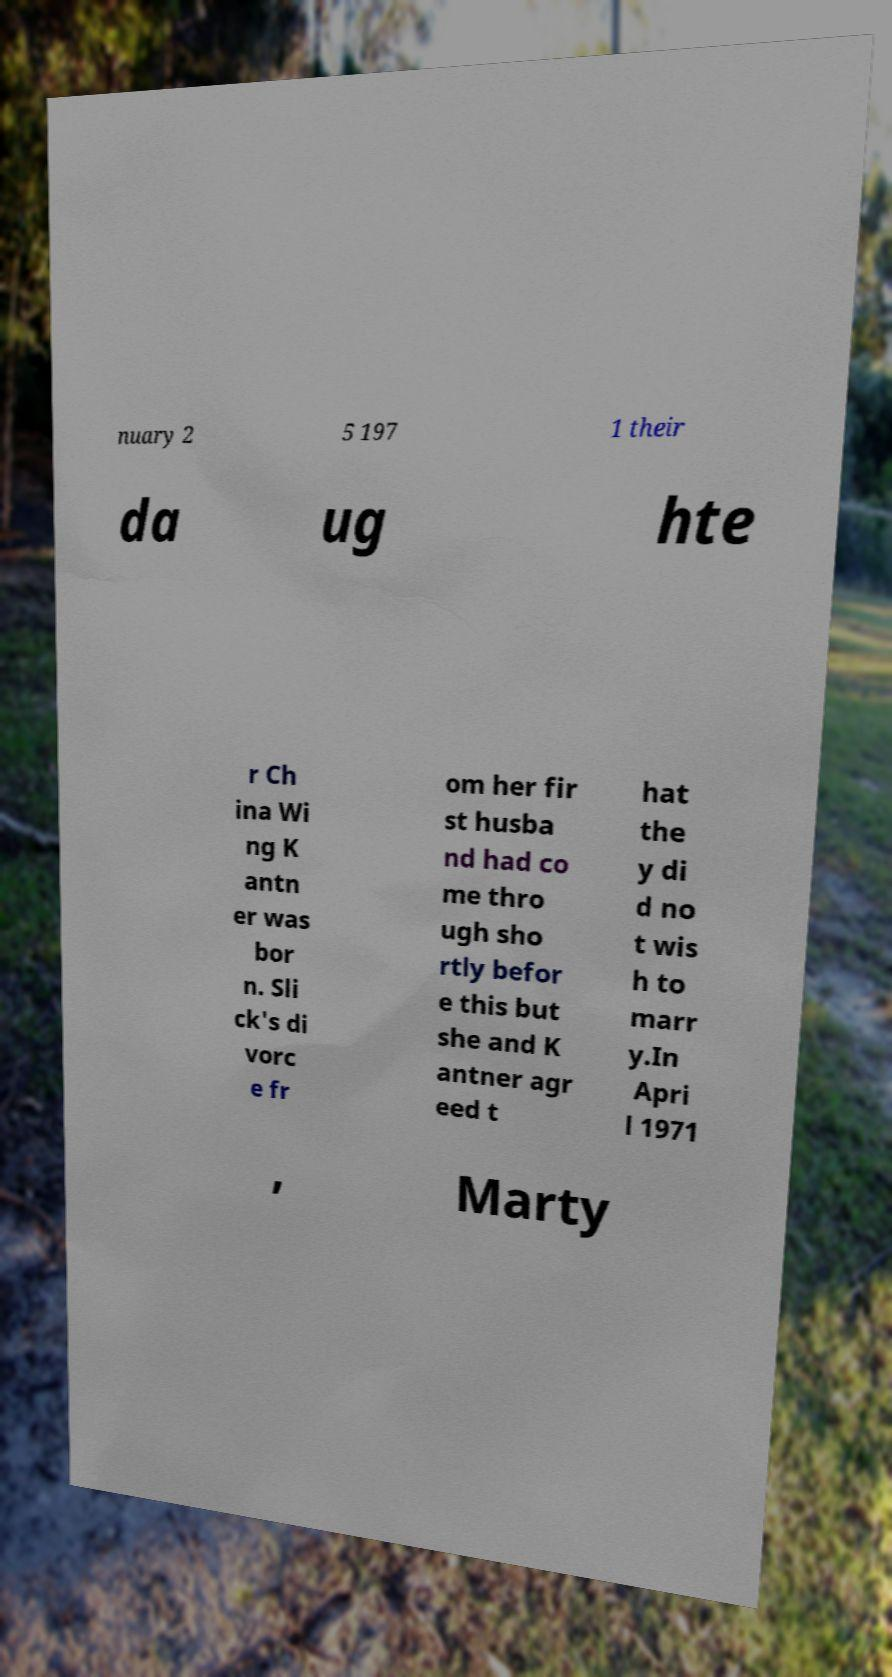There's text embedded in this image that I need extracted. Can you transcribe it verbatim? nuary 2 5 197 1 their da ug hte r Ch ina Wi ng K antn er was bor n. Sli ck's di vorc e fr om her fir st husba nd had co me thro ugh sho rtly befor e this but she and K antner agr eed t hat the y di d no t wis h to marr y.In Apri l 1971 , Marty 